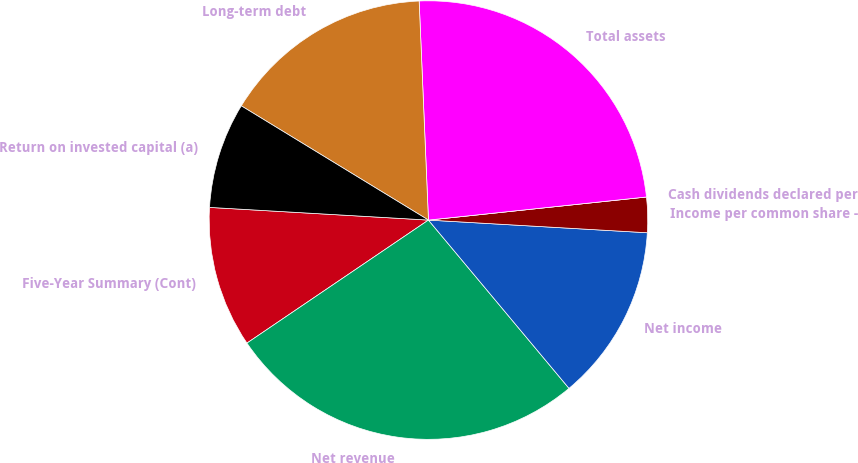Convert chart to OTSL. <chart><loc_0><loc_0><loc_500><loc_500><pie_chart><fcel>Five-Year Summary (Cont)<fcel>Net revenue<fcel>Net income<fcel>Income per common share -<fcel>Cash dividends declared per<fcel>Total assets<fcel>Long-term debt<fcel>Return on invested capital (a)<nl><fcel>10.4%<fcel>26.59%<fcel>13.0%<fcel>2.6%<fcel>0.0%<fcel>23.99%<fcel>15.6%<fcel>7.8%<nl></chart> 